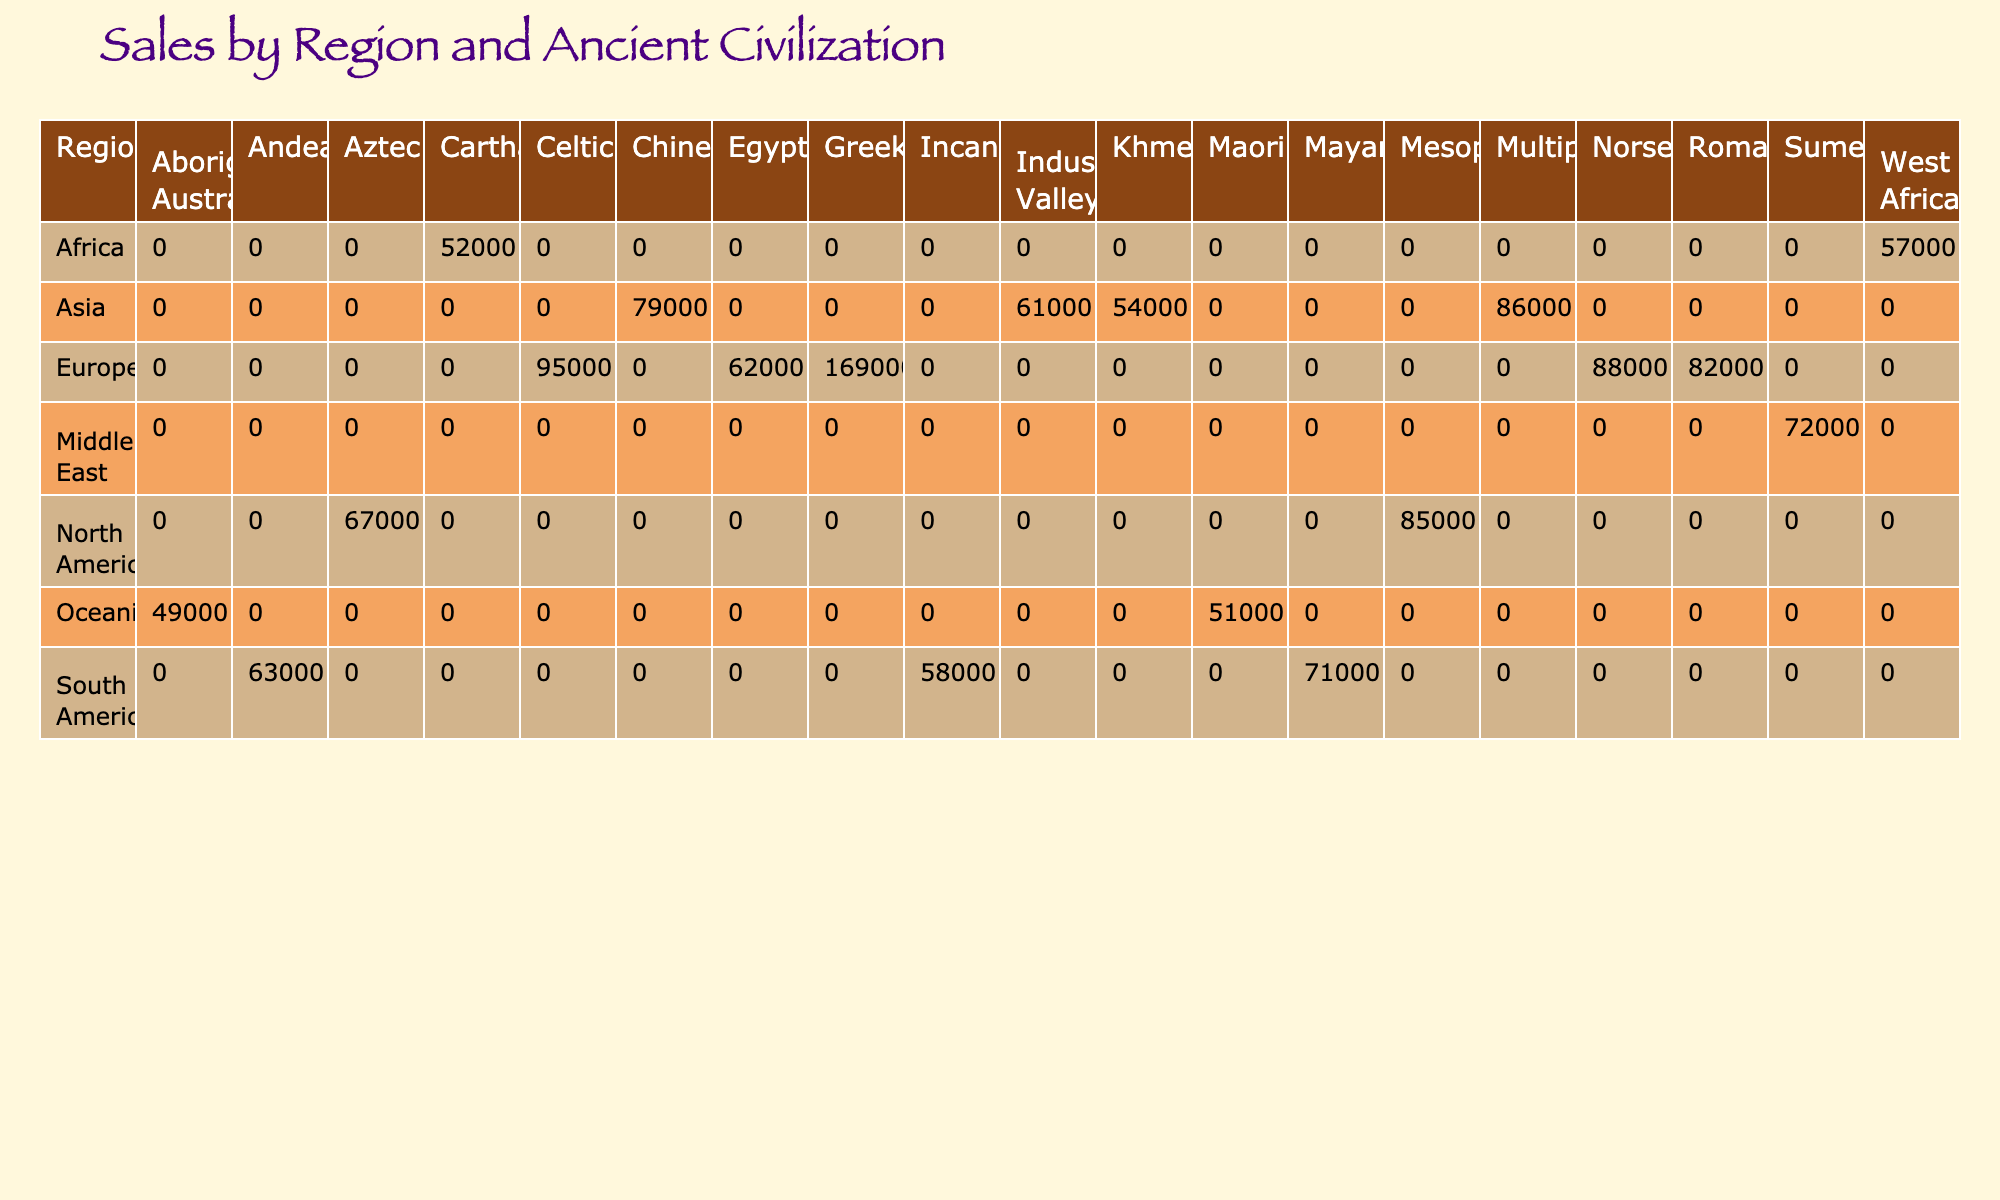What is the total sales for the Egyptian civilization in Europe? From the table, the Egyptian civilization in Europe has one entry: "Ramesses II: Ozymandias" with sales of 62000. Therefore, the total sales for the Egyptian civilization in this region is simply 62000.
Answer: 62000 Which region had the highest sales for the Greek civilization? The table shows two entries for the Greek civilization: "The Odyssey Reimagined" with sales of 93000 and "The Trojan Saga" with sales of 76000 in Europe. The highest sales among these is 93000.
Answer: 93000 Are there any graphic novels featuring the Incan civilization that won any awards? Referring to the table, "The Last Inca" featuring the Incan civilization in South America has sales of 58000 and won 0 awards. Therefore, there are no entries for the Incan civilization that won awards.
Answer: No What is the average sales for graphic novels in Asia? In Asia, the entries in the table are "Journey to Chang'an" (79000), "Tales from Mohenjodaro" (61000), and "Secrets of Angkor" (54000). To calculate the average, sum these sales: 79000 + 61000 + 54000 = 194000 and divide by the number of entries (3), resulting in an average of 194000 / 3 ≈ 64667.
Answer: 64667 Which ancient civilization has the lowest sales in North America? In North America, there is one entry for the Aztec civilization with sales of 67000 and no mention of other civilizations in North America from the data provided. Therefore, the Aztec civilization has the lowest sales by default.
Answer: Aztec What are the total sales for all graphic novels in Europe featuring the Roman civilization? In the table, there is one entry for the Roman civilization: "Roman Emperors" with sales of 82000. Thus, the total sales for Roman graphic novels in Europe is simply 82000.
Answer: 82000 Did any books featuring the Mayan civilization win more than one award? Referring to the entries in the table, "Mayan Prophecies" features the Mayan civilization and has won 1 award. There are no entries that indicate that more than one award is given for this civilization. Therefore, the answer is no.
Answer: No What is the total number of awards won by graphic novels featuring the Norse civilization in Europe? There is one entry for the Norse civilization in Europe: "Norse Myths: Ragnarok" which won 1 award. Therefore, the total number of awards for the Norse civilization is 1.
Answer: 1 